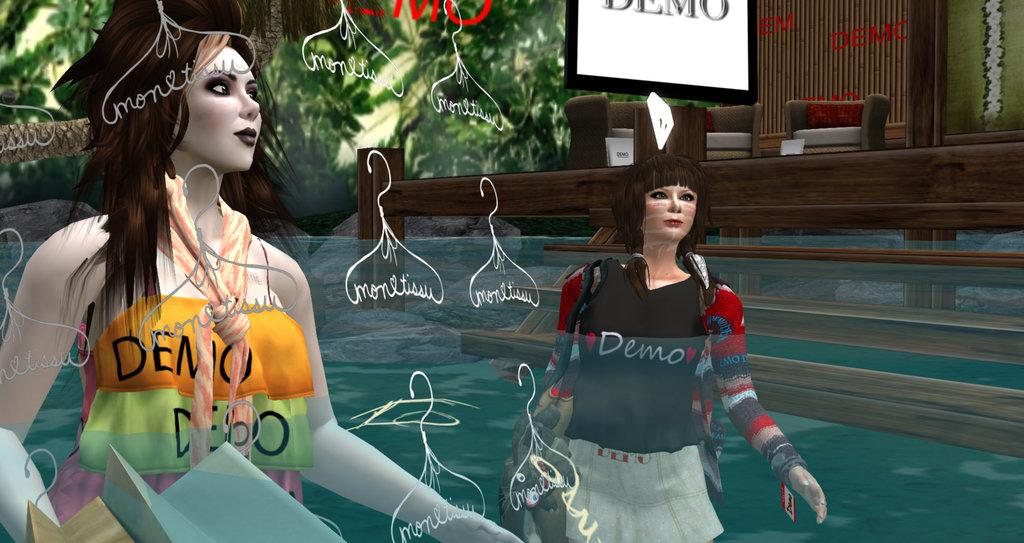What is the main subject of the image? There is a graphic in the image. What are the two women in the image doing? The two women are standing in the water. What structure is located on the right side of the image? There is a house on the right side of the image. What can be seen in the background of the image? There are trees in the background of the image. What type of butter is being used by the women in the image? There is no butter present in the image; the two women are standing in the water. How many stitches can be seen on the graphic in the image? The provided facts do not mention any stitches on the graphic, so it cannot be determined from the image. 